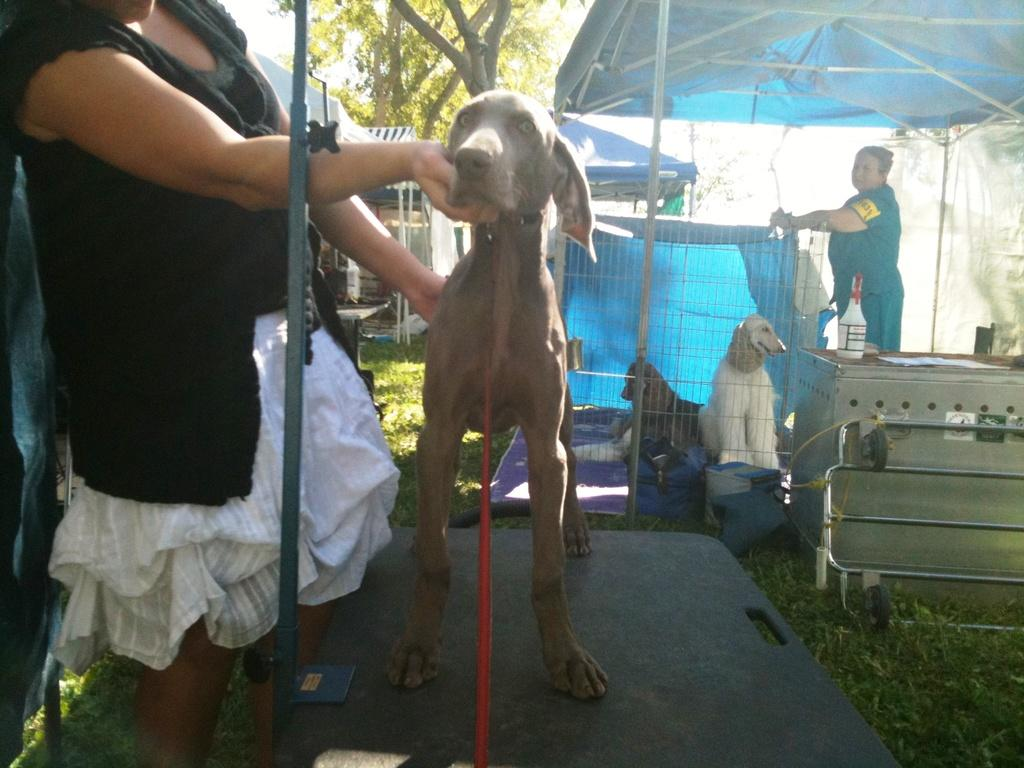How many people are in the image? There are two women standing in the image. What other living creatures are present in the image? There are dogs in the image. What type of plant can be seen in the image? There is a tree in the image. What type of egg is being used as a hobby by one of the women in the image? There is no egg or reference to a hobby present in the image. 